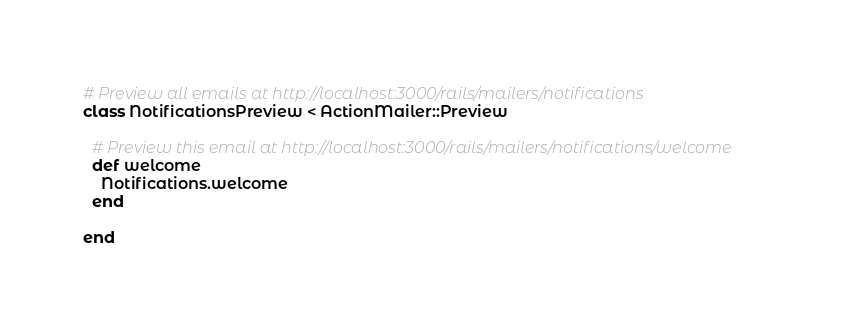Convert code to text. <code><loc_0><loc_0><loc_500><loc_500><_Ruby_># Preview all emails at http://localhost:3000/rails/mailers/notifications
class NotificationsPreview < ActionMailer::Preview

  # Preview this email at http://localhost:3000/rails/mailers/notifications/welcome
  def welcome
    Notifications.welcome
  end

end
</code> 